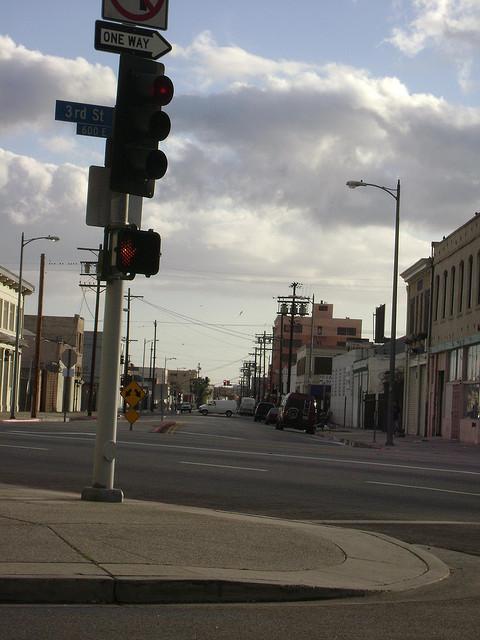Would a car stop at this stoplight?
Short answer required. Yes. Is this a summer day?
Short answer required. No. What are the signs connected to?
Short answer required. Pole. What do the signs in this picture indicate to traffic?
Quick response, please. 1 way. Which direction is one-way?
Answer briefly. Right. What color is the light?
Concise answer only. Red. Is the white building the White House?
Answer briefly. No. 